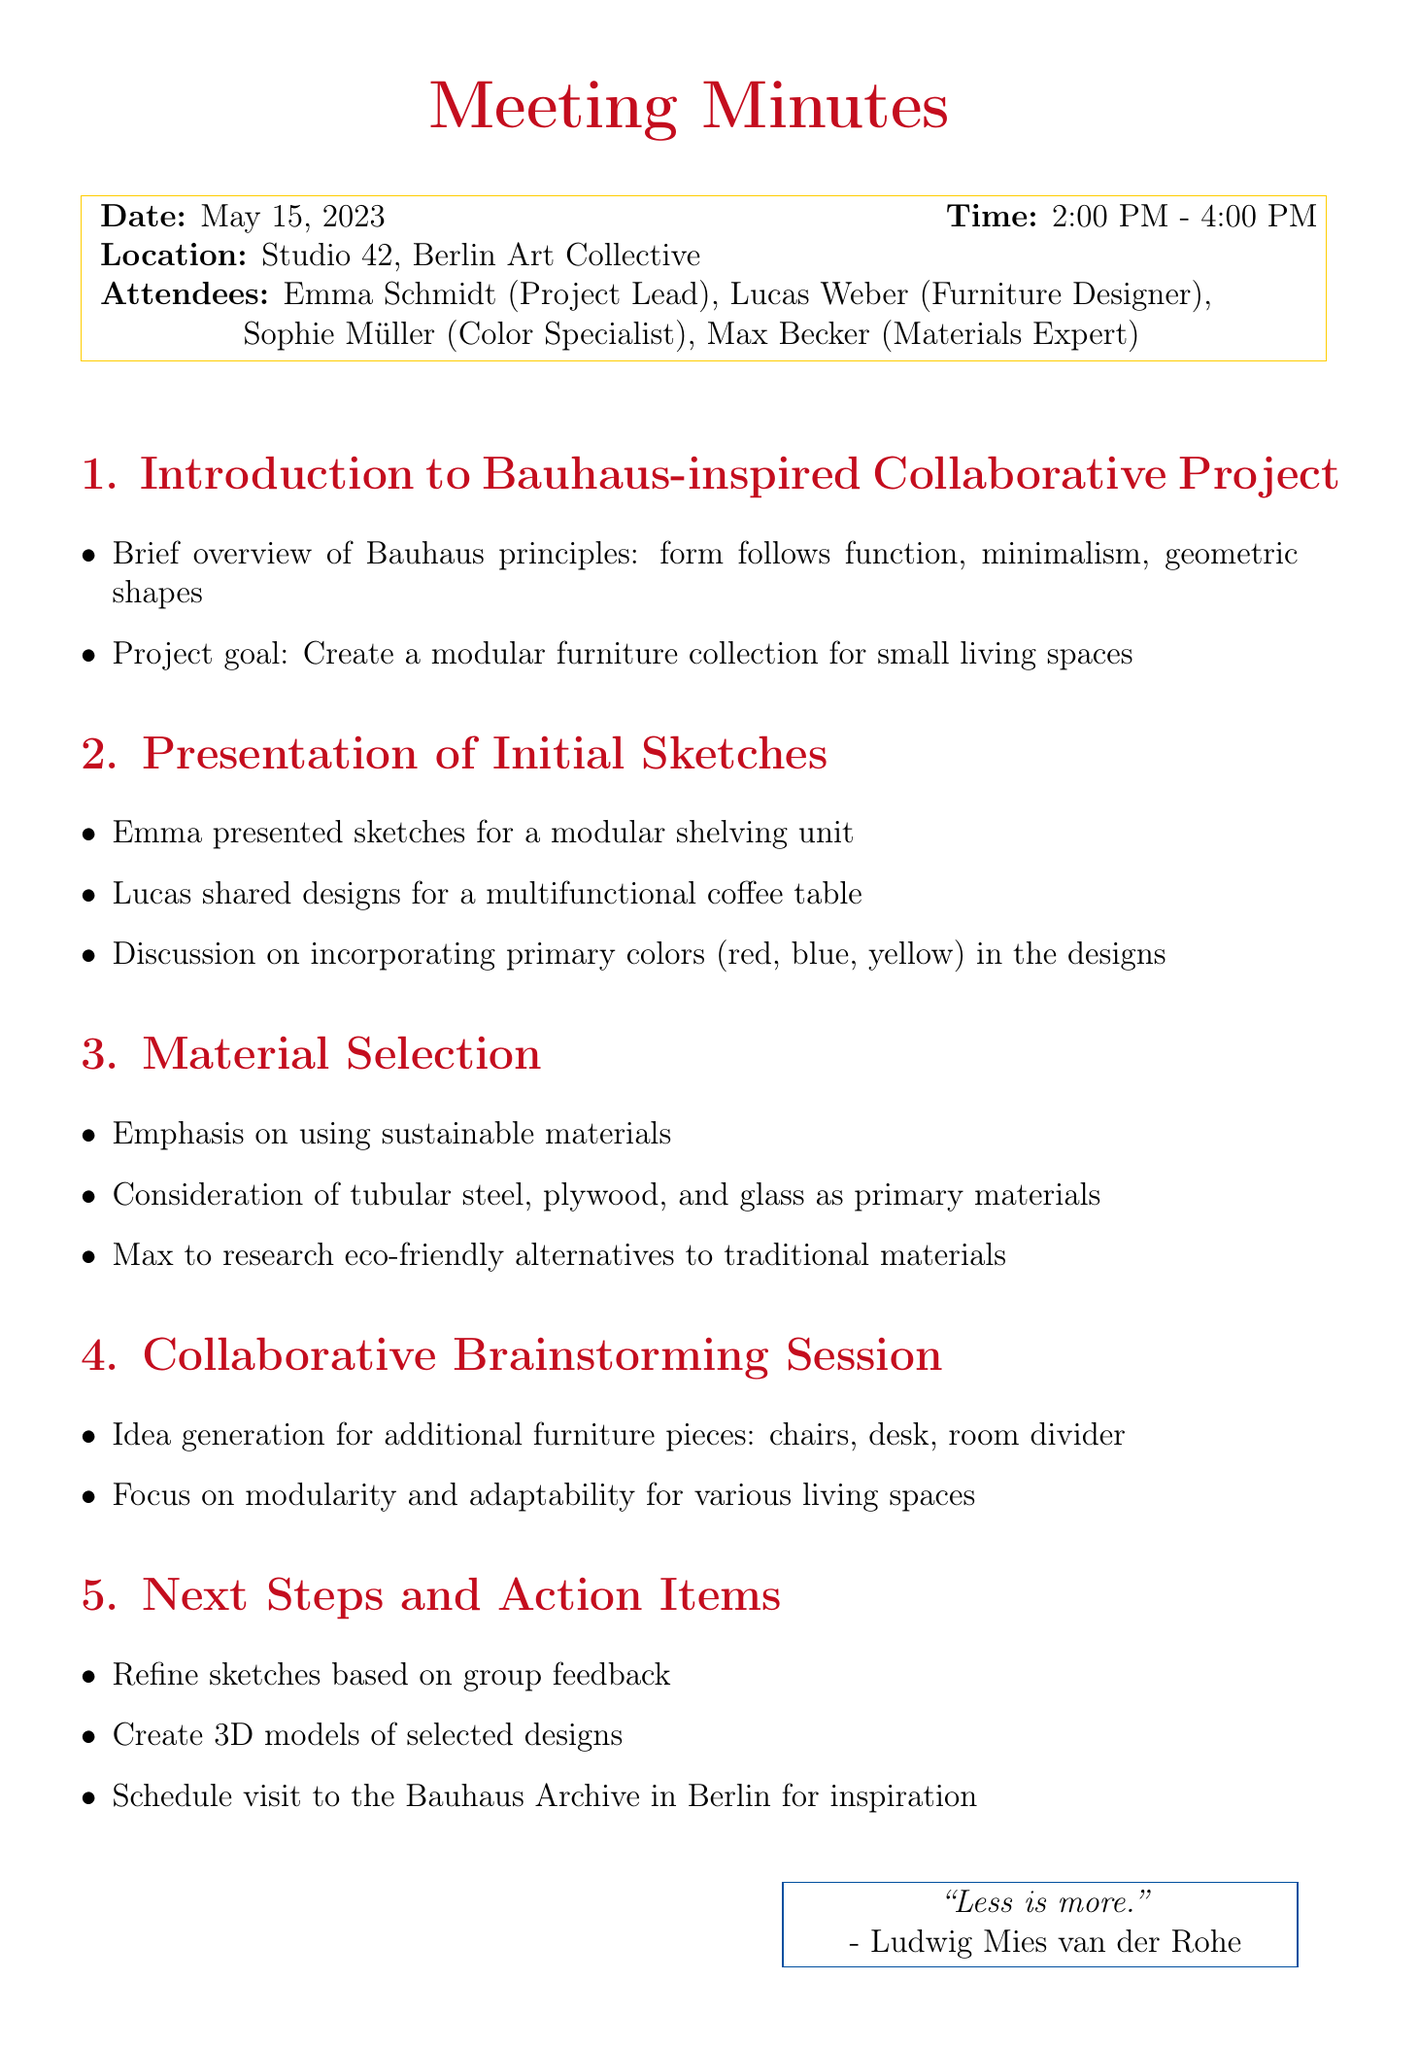what date did the meeting take place? The meeting date is specified clearly at the beginning of the document.
Answer: May 15, 2023 who is the project lead? The document lists Emma Schmidt as the project lead in the attendees section.
Answer: Emma Schmidt what type of furniture is the project focused on? The document mentions the project goal which specifies the type of furniture being created.
Answer: Modular furniture which colors are discussed for incorporation in the designs? The document lists the specific colors considered during the design discussion.
Answer: Red, blue, yellow what main materials are suggested for the furniture? The material selection section mentions specific materials that were discussed for use.
Answer: Tubular steel, plywood, glass how long did the meeting last? The document indicates the start and end time of the meeting to determine duration.
Answer: 2 hours what is one of the action items after the meeting? The next steps section outlines what actions were decided upon after the meeting.
Answer: Refine sketches based on group feedback where is the Bauhaus Archive located? The document details the context of scheduling a visit related to the project.
Answer: Berlin 